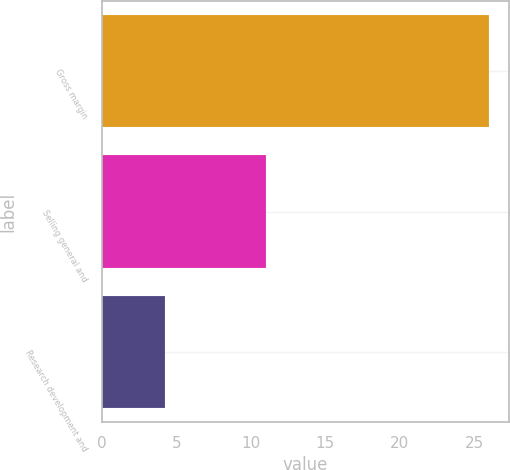Convert chart to OTSL. <chart><loc_0><loc_0><loc_500><loc_500><bar_chart><fcel>Gross margin<fcel>Selling general and<fcel>Research development and<nl><fcel>26<fcel>11<fcel>4.2<nl></chart> 